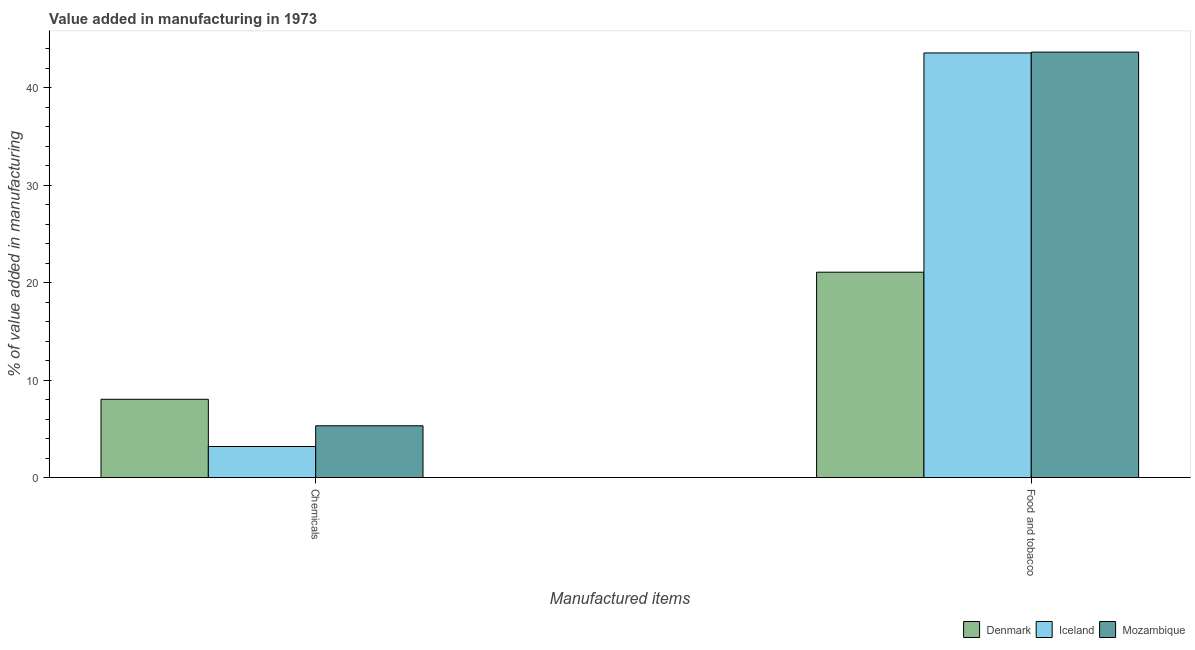What is the label of the 1st group of bars from the left?
Offer a terse response. Chemicals. What is the value added by  manufacturing chemicals in Iceland?
Your response must be concise. 3.19. Across all countries, what is the maximum value added by manufacturing food and tobacco?
Ensure brevity in your answer.  43.65. Across all countries, what is the minimum value added by manufacturing food and tobacco?
Your response must be concise. 21.07. In which country was the value added by  manufacturing chemicals maximum?
Ensure brevity in your answer.  Denmark. What is the total value added by  manufacturing chemicals in the graph?
Your answer should be very brief. 16.53. What is the difference between the value added by manufacturing food and tobacco in Iceland and that in Denmark?
Provide a short and direct response. 22.49. What is the difference between the value added by manufacturing food and tobacco in Mozambique and the value added by  manufacturing chemicals in Iceland?
Offer a very short reply. 40.47. What is the average value added by manufacturing food and tobacco per country?
Make the answer very short. 36.1. What is the difference between the value added by  manufacturing chemicals and value added by manufacturing food and tobacco in Denmark?
Give a very brief answer. -13.04. What is the ratio of the value added by manufacturing food and tobacco in Iceland to that in Mozambique?
Your answer should be very brief. 1. In how many countries, is the value added by  manufacturing chemicals greater than the average value added by  manufacturing chemicals taken over all countries?
Provide a succinct answer. 1. What does the 2nd bar from the left in Food and tobacco represents?
Provide a short and direct response. Iceland. What does the 2nd bar from the right in Chemicals represents?
Your answer should be very brief. Iceland. Are all the bars in the graph horizontal?
Your response must be concise. No. How many countries are there in the graph?
Your answer should be compact. 3. What is the difference between two consecutive major ticks on the Y-axis?
Ensure brevity in your answer.  10. Where does the legend appear in the graph?
Provide a short and direct response. Bottom right. How many legend labels are there?
Your response must be concise. 3. How are the legend labels stacked?
Ensure brevity in your answer.  Horizontal. What is the title of the graph?
Provide a succinct answer. Value added in manufacturing in 1973. Does "Uganda" appear as one of the legend labels in the graph?
Your response must be concise. No. What is the label or title of the X-axis?
Your answer should be very brief. Manufactured items. What is the label or title of the Y-axis?
Ensure brevity in your answer.  % of value added in manufacturing. What is the % of value added in manufacturing in Denmark in Chemicals?
Provide a short and direct response. 8.03. What is the % of value added in manufacturing in Iceland in Chemicals?
Offer a very short reply. 3.19. What is the % of value added in manufacturing of Mozambique in Chemicals?
Keep it short and to the point. 5.31. What is the % of value added in manufacturing of Denmark in Food and tobacco?
Offer a terse response. 21.07. What is the % of value added in manufacturing of Iceland in Food and tobacco?
Offer a very short reply. 43.56. What is the % of value added in manufacturing of Mozambique in Food and tobacco?
Provide a short and direct response. 43.65. Across all Manufactured items, what is the maximum % of value added in manufacturing of Denmark?
Make the answer very short. 21.07. Across all Manufactured items, what is the maximum % of value added in manufacturing of Iceland?
Offer a terse response. 43.56. Across all Manufactured items, what is the maximum % of value added in manufacturing of Mozambique?
Provide a succinct answer. 43.65. Across all Manufactured items, what is the minimum % of value added in manufacturing of Denmark?
Make the answer very short. 8.03. Across all Manufactured items, what is the minimum % of value added in manufacturing in Iceland?
Offer a terse response. 3.19. Across all Manufactured items, what is the minimum % of value added in manufacturing of Mozambique?
Offer a terse response. 5.31. What is the total % of value added in manufacturing in Denmark in the graph?
Your response must be concise. 29.1. What is the total % of value added in manufacturing of Iceland in the graph?
Keep it short and to the point. 46.75. What is the total % of value added in manufacturing of Mozambique in the graph?
Your answer should be very brief. 48.96. What is the difference between the % of value added in manufacturing in Denmark in Chemicals and that in Food and tobacco?
Give a very brief answer. -13.04. What is the difference between the % of value added in manufacturing of Iceland in Chemicals and that in Food and tobacco?
Ensure brevity in your answer.  -40.38. What is the difference between the % of value added in manufacturing in Mozambique in Chemicals and that in Food and tobacco?
Give a very brief answer. -38.34. What is the difference between the % of value added in manufacturing of Denmark in Chemicals and the % of value added in manufacturing of Iceland in Food and tobacco?
Your answer should be very brief. -35.53. What is the difference between the % of value added in manufacturing in Denmark in Chemicals and the % of value added in manufacturing in Mozambique in Food and tobacco?
Keep it short and to the point. -35.62. What is the difference between the % of value added in manufacturing of Iceland in Chemicals and the % of value added in manufacturing of Mozambique in Food and tobacco?
Give a very brief answer. -40.47. What is the average % of value added in manufacturing of Denmark per Manufactured items?
Provide a short and direct response. 14.55. What is the average % of value added in manufacturing of Iceland per Manufactured items?
Your response must be concise. 23.38. What is the average % of value added in manufacturing of Mozambique per Manufactured items?
Provide a short and direct response. 24.48. What is the difference between the % of value added in manufacturing of Denmark and % of value added in manufacturing of Iceland in Chemicals?
Ensure brevity in your answer.  4.84. What is the difference between the % of value added in manufacturing in Denmark and % of value added in manufacturing in Mozambique in Chemicals?
Ensure brevity in your answer.  2.72. What is the difference between the % of value added in manufacturing of Iceland and % of value added in manufacturing of Mozambique in Chemicals?
Provide a short and direct response. -2.13. What is the difference between the % of value added in manufacturing in Denmark and % of value added in manufacturing in Iceland in Food and tobacco?
Provide a short and direct response. -22.49. What is the difference between the % of value added in manufacturing of Denmark and % of value added in manufacturing of Mozambique in Food and tobacco?
Provide a succinct answer. -22.58. What is the difference between the % of value added in manufacturing in Iceland and % of value added in manufacturing in Mozambique in Food and tobacco?
Ensure brevity in your answer.  -0.09. What is the ratio of the % of value added in manufacturing in Denmark in Chemicals to that in Food and tobacco?
Your answer should be very brief. 0.38. What is the ratio of the % of value added in manufacturing in Iceland in Chemicals to that in Food and tobacco?
Your answer should be very brief. 0.07. What is the ratio of the % of value added in manufacturing in Mozambique in Chemicals to that in Food and tobacco?
Keep it short and to the point. 0.12. What is the difference between the highest and the second highest % of value added in manufacturing in Denmark?
Your response must be concise. 13.04. What is the difference between the highest and the second highest % of value added in manufacturing in Iceland?
Your response must be concise. 40.38. What is the difference between the highest and the second highest % of value added in manufacturing in Mozambique?
Keep it short and to the point. 38.34. What is the difference between the highest and the lowest % of value added in manufacturing in Denmark?
Your answer should be very brief. 13.04. What is the difference between the highest and the lowest % of value added in manufacturing in Iceland?
Offer a terse response. 40.38. What is the difference between the highest and the lowest % of value added in manufacturing of Mozambique?
Your answer should be very brief. 38.34. 